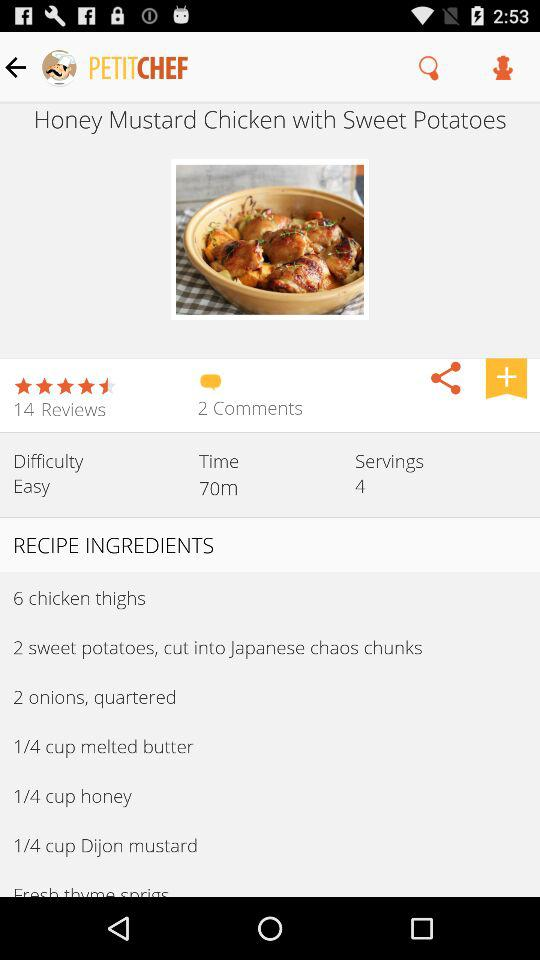What is the difficulty level of the recipe? The difficulty level of the recipe is "Easy". 